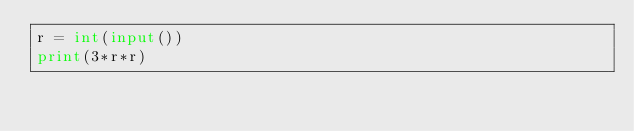<code> <loc_0><loc_0><loc_500><loc_500><_Python_>r = int(input())
print(3*r*r)</code> 